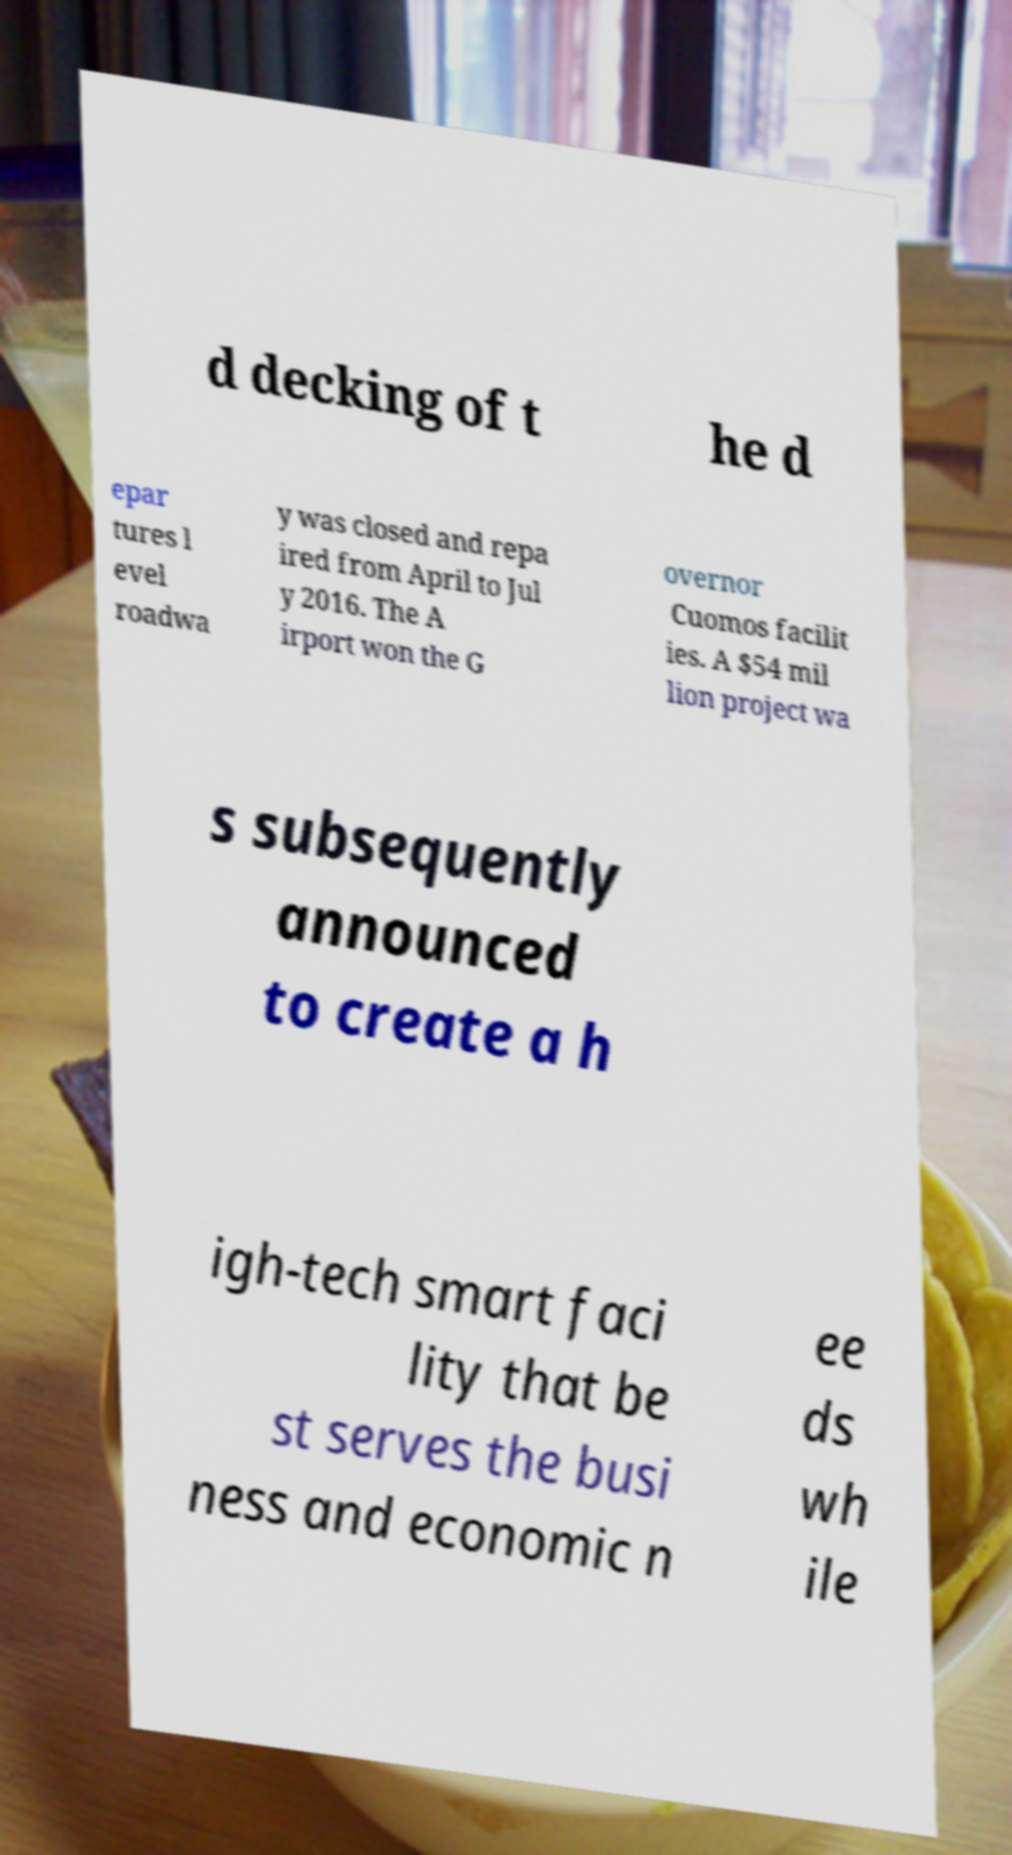Could you extract and type out the text from this image? d decking of t he d epar tures l evel roadwa y was closed and repa ired from April to Jul y 2016. The A irport won the G overnor Cuomos facilit ies. A $54 mil lion project wa s subsequently announced to create a h igh-tech smart faci lity that be st serves the busi ness and economic n ee ds wh ile 